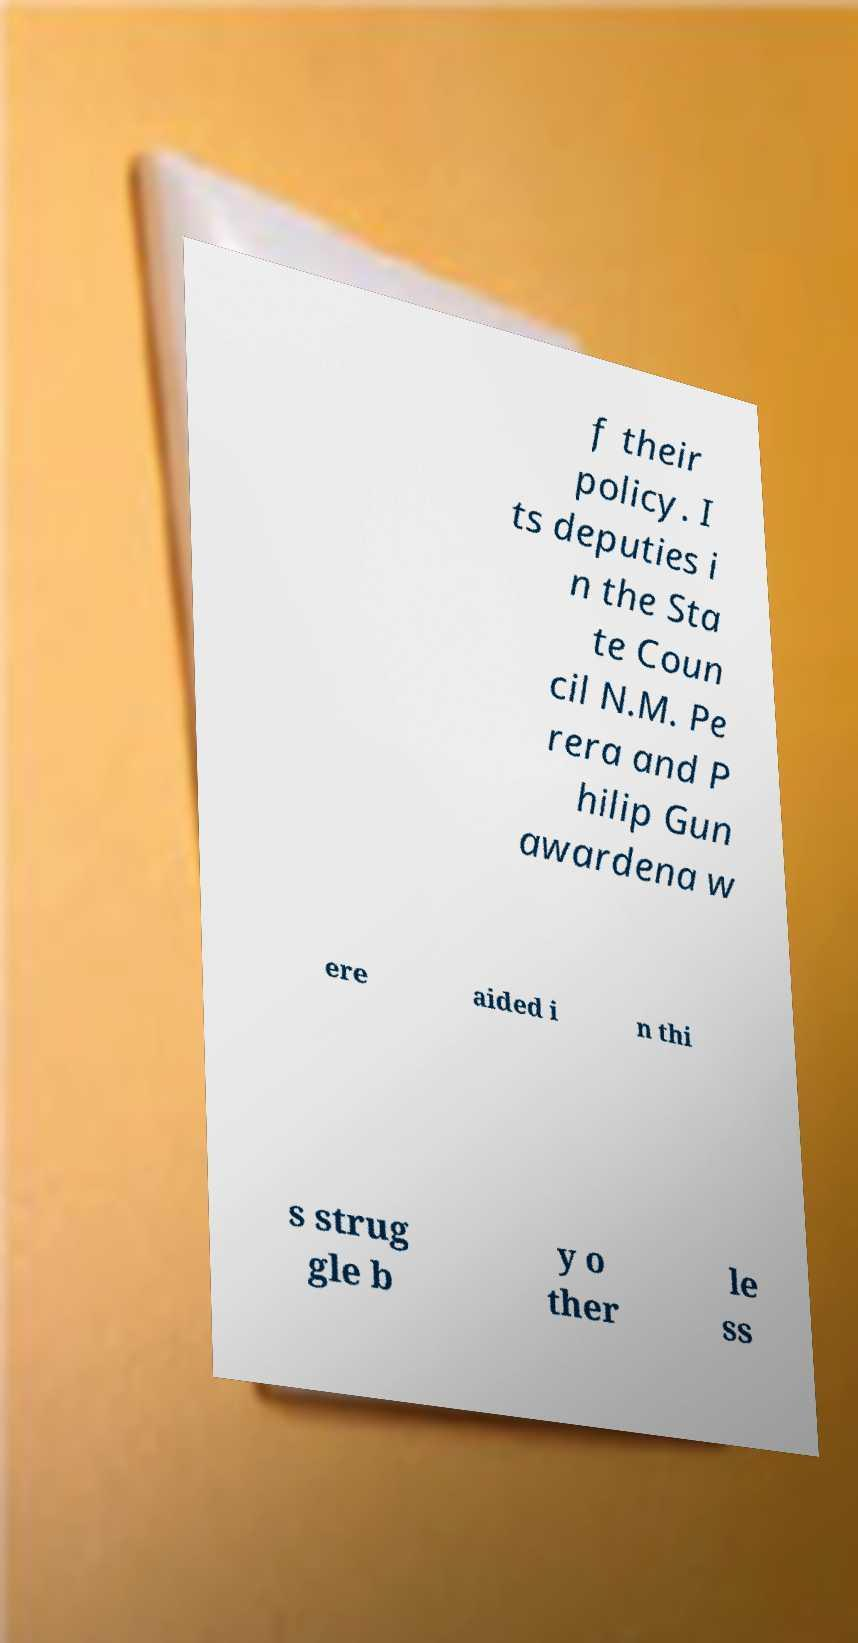Could you assist in decoding the text presented in this image and type it out clearly? f their policy. I ts deputies i n the Sta te Coun cil N.M. Pe rera and P hilip Gun awardena w ere aided i n thi s strug gle b y o ther le ss 